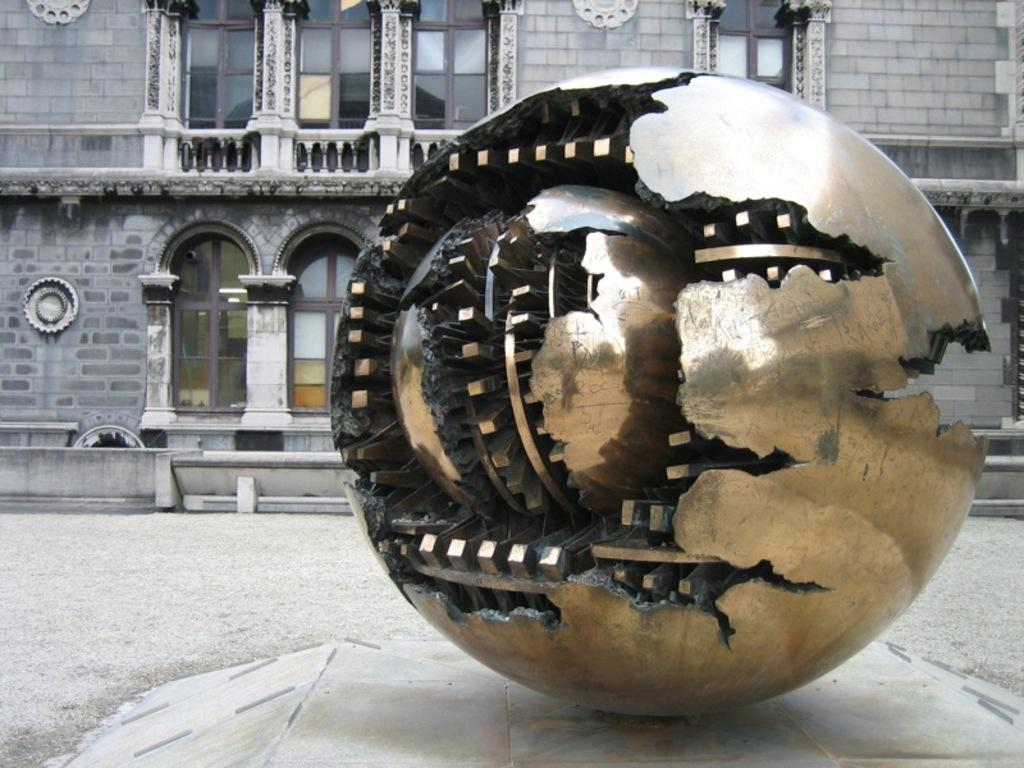What is the main subject of the image? There is a sculpture in the image. Where is the sculpture located in relation to other objects or structures? The sculpture is in front of a building. How does the spoon provide comfort to the sculpture in the image? There is no spoon present in the image, and therefore it cannot provide comfort to the sculpture. 